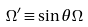<formula> <loc_0><loc_0><loc_500><loc_500>\Omega ^ { \prime } \equiv \sin { \theta } \Omega</formula> 